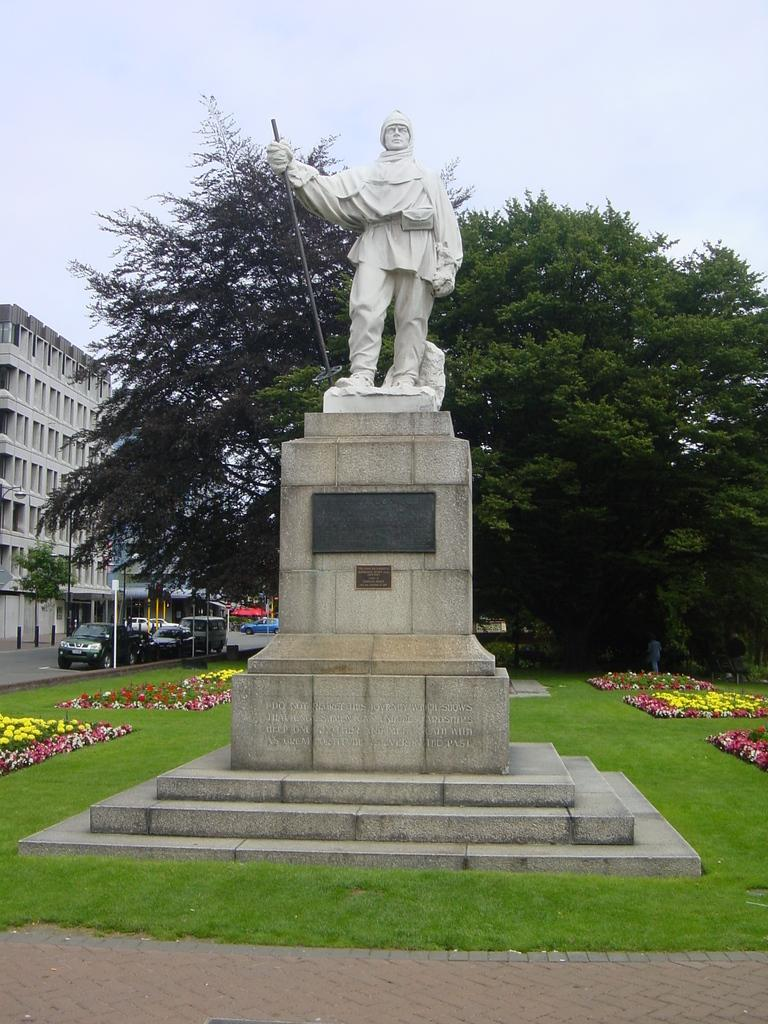What is the main subject in the image? There is a statue of a person in the image. What type of ground is visible in the image? There is grass on the ground in the image. What other natural elements can be seen on the ground? There are flowers on the ground in the image. What can be seen in the background of the image? There are trees, cars, and a building in the background of the image. What type of addition problem can be solved using the numbers on the statue's base? There is no addition problem or numbers visible on the statue's base in the image. 